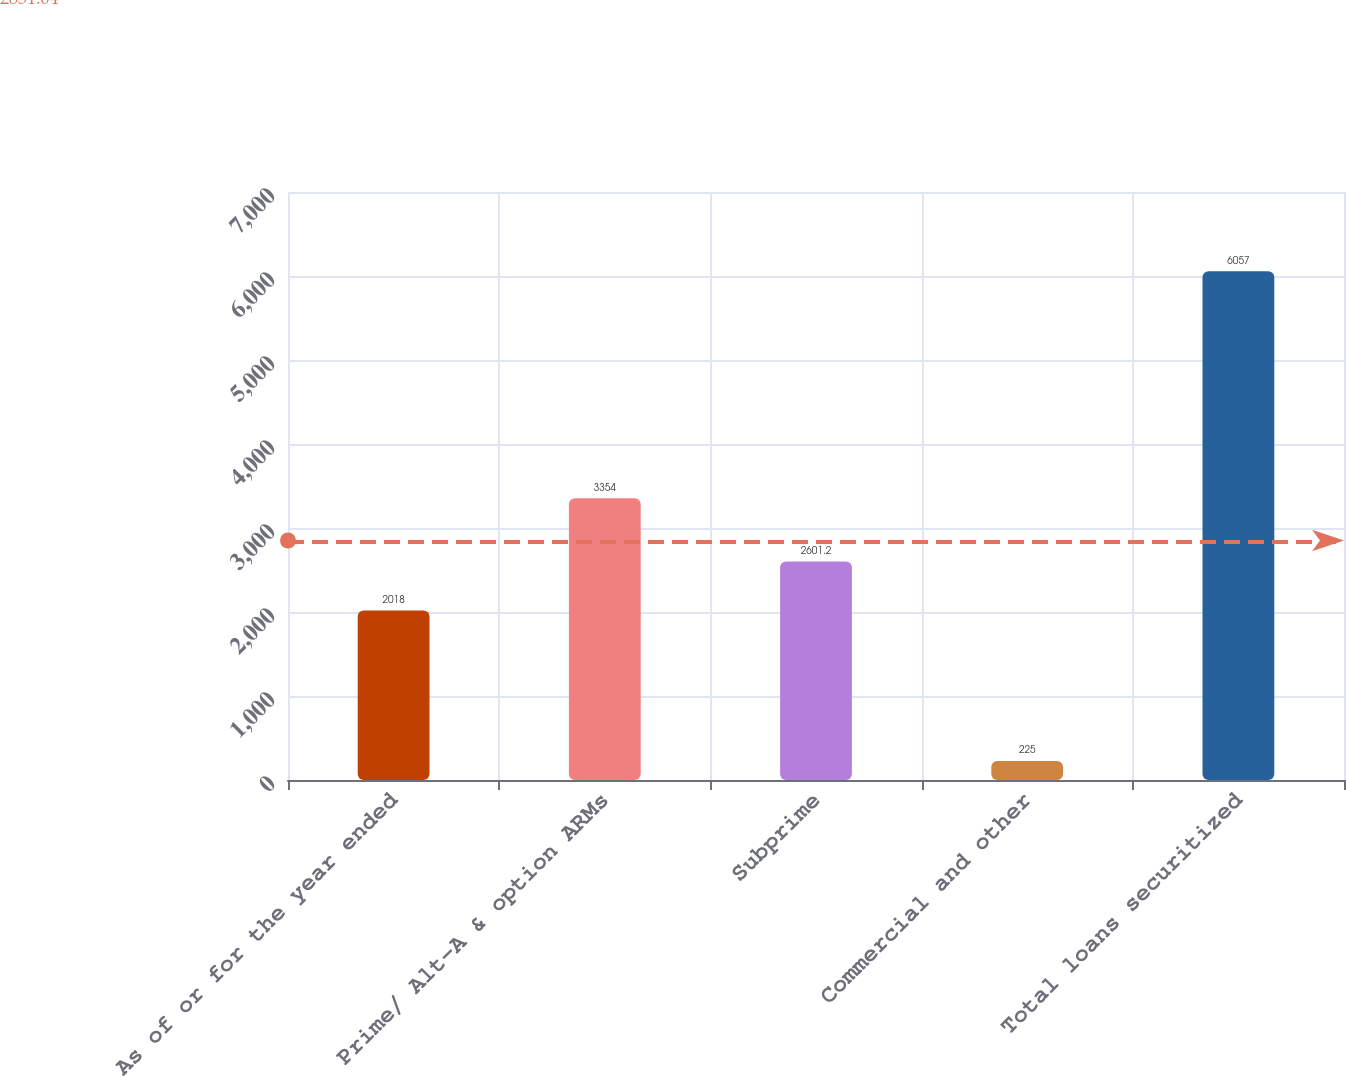Convert chart to OTSL. <chart><loc_0><loc_0><loc_500><loc_500><bar_chart><fcel>As of or for the year ended<fcel>Prime/ Alt-A & option ARMs<fcel>Subprime<fcel>Commercial and other<fcel>Total loans securitized<nl><fcel>2018<fcel>3354<fcel>2601.2<fcel>225<fcel>6057<nl></chart> 